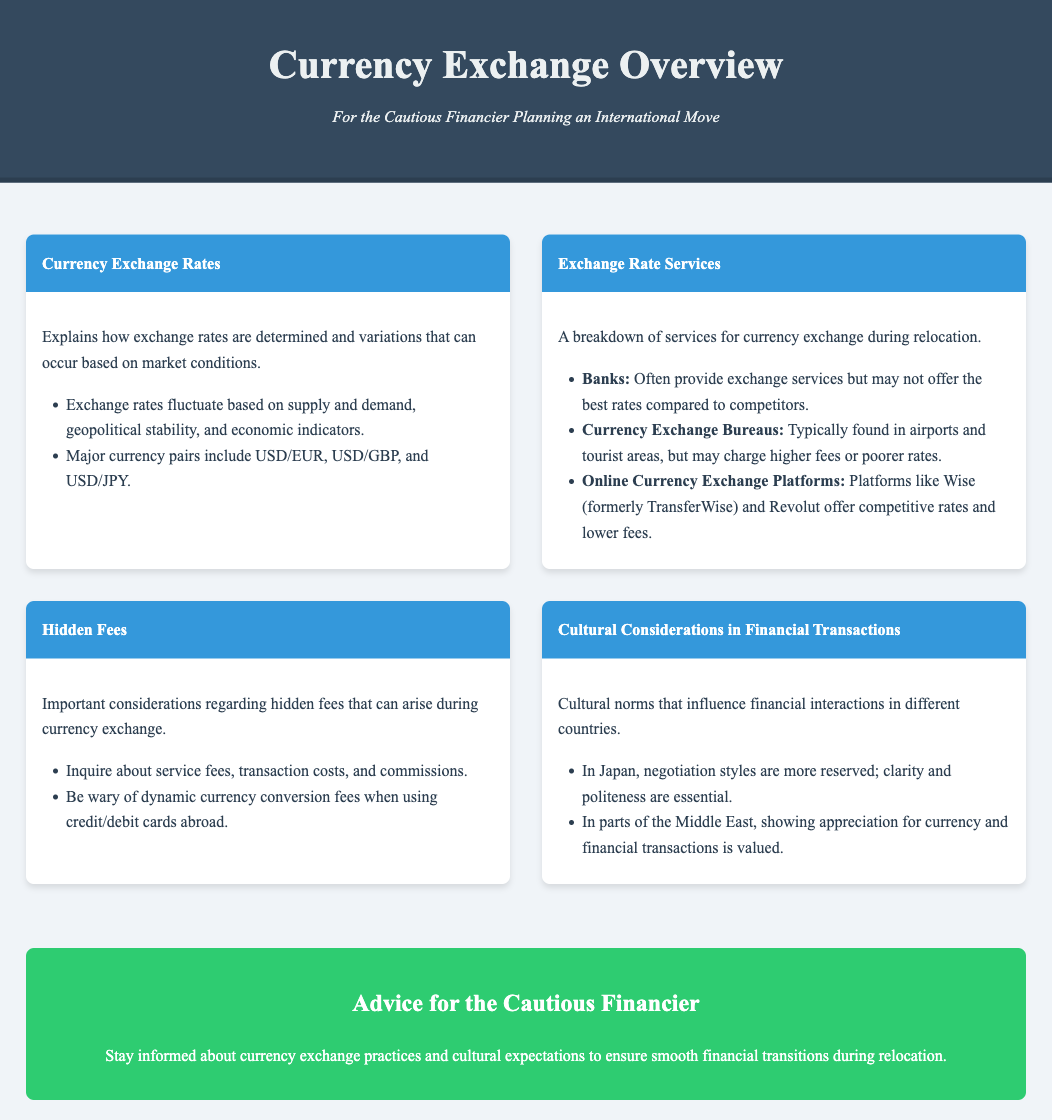What are the major currency pairs mentioned? The document lists major currency pairs including USD/EUR, USD/GBP, and USD/JPY.
Answer: USD/EUR, USD/GBP, USD/JPY What services do banks offer for currency exchange? Banks provide exchange services but may not offer the best rates compared to competitors.
Answer: Exchange services What is a potential hidden fee mentioned? The document advises to be wary of dynamic currency conversion fees when using credit/debit cards abroad.
Answer: Dynamic currency conversion fees What is one cultural consideration in financial transactions in Japan? In Japan, negotiation styles are more reserved; clarity and politeness are essential during transactions.
Answer: Clarity and politeness Which online platforms are recommended for currency exchange? Platforms like Wise (formerly TransferWise) and Revolut offer competitive rates and lower fees.
Answer: Wise, Revolut What does the conclusion advise for cautious financiers? The conclusion advises staying informed about currency exchange practices and cultural expectations.
Answer: Stay informed 